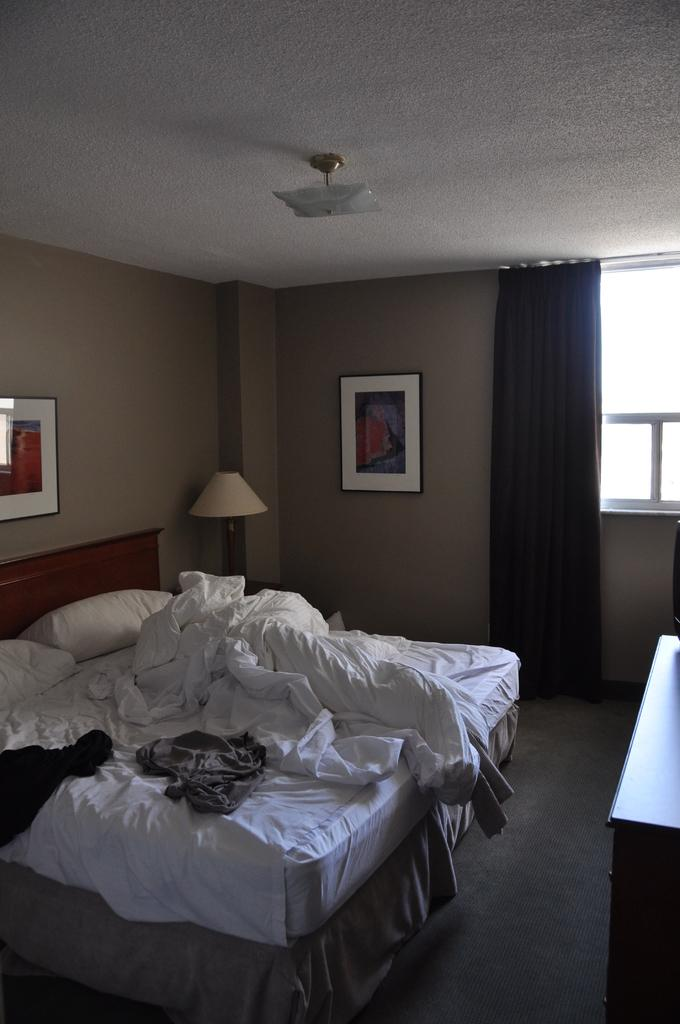What type of furniture is located on the left side of the image? There is a bed on the left side of the image. What is in the corner of the image? There is a lamp in the corner of the image. What is associated with the curtain in the image? There is a window associated with the curtain. Can you describe the curtain in the image? The curtain is located on the right side of the image. What type of cracker is being used to prop open the window in the image? There is no cracker present in the image, nor is there any indication that the window is propped open. What type of cabbage is visible on the bed in the image? There is no cabbage present in the image; the bed contains a bedspread or sheets, not vegetables. 